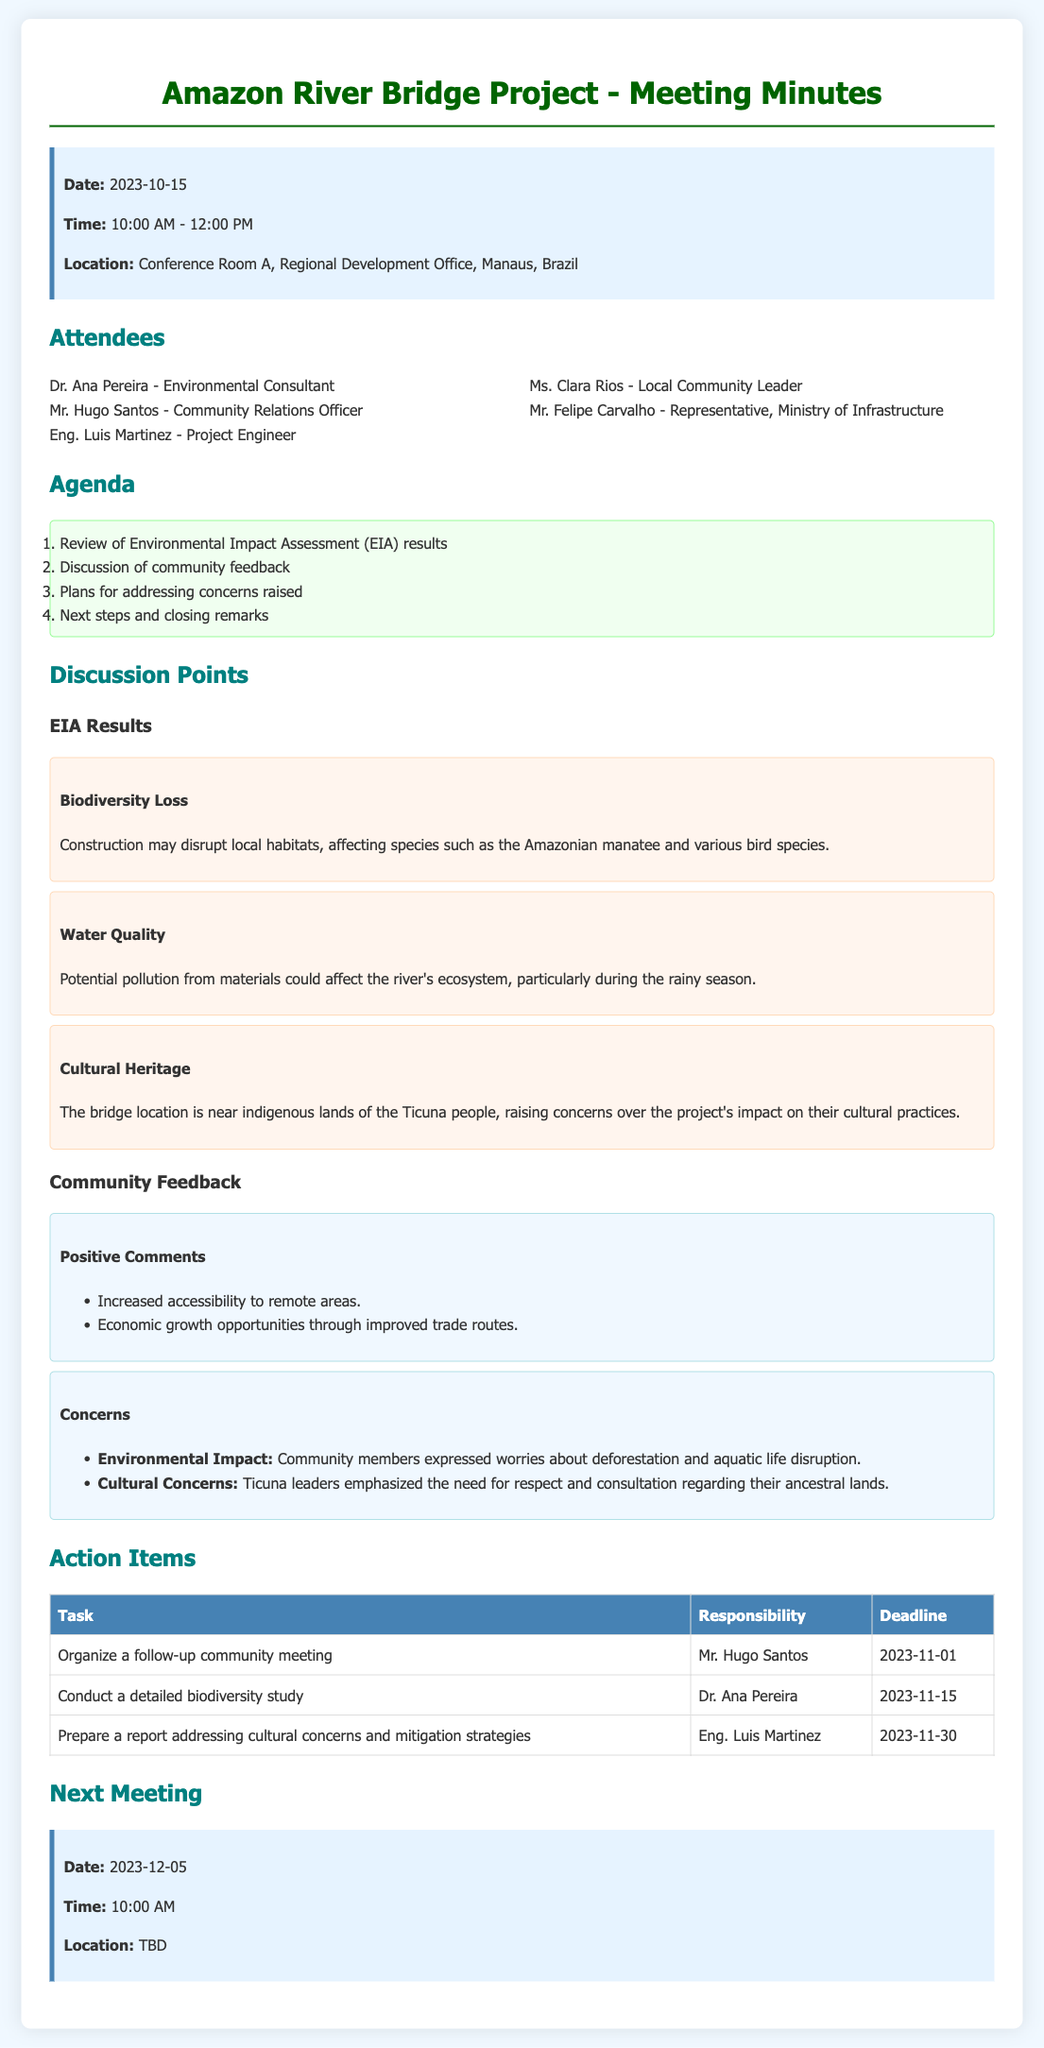What is the date of the meeting? The date is specified at the beginning of the minutes document.
Answer: 2023-10-15 Who is the Environmental Consultant? The attendees list includes names and their respective roles in the project.
Answer: Dr. Ana Pereira What was one of the positive comments from the community? The document lists feedback from the community regarding the project.
Answer: Increased accessibility to remote areas What is the deadline for organizing a follow-up community meeting? The action items section specifies deadlines for each task assigned.
Answer: 2023-11-01 What concern did community members express regarding environmental impact? The concerns are grouped under community feedback as listed in the document.
Answer: Deforestation and aquatic life disruption Who is responsible for conducting a detailed biodiversity study? The responsibility for tasks is outlined in the action items table.
Answer: Dr. Ana Pereira What is the location of the next meeting? The next meeting details are provided at the end of the minutes document.
Answer: TBD What is one of the impacts related to water quality identified in the EIA results? The document discusses specific impacts relating to the environmental assessment.
Answer: Potential pollution 